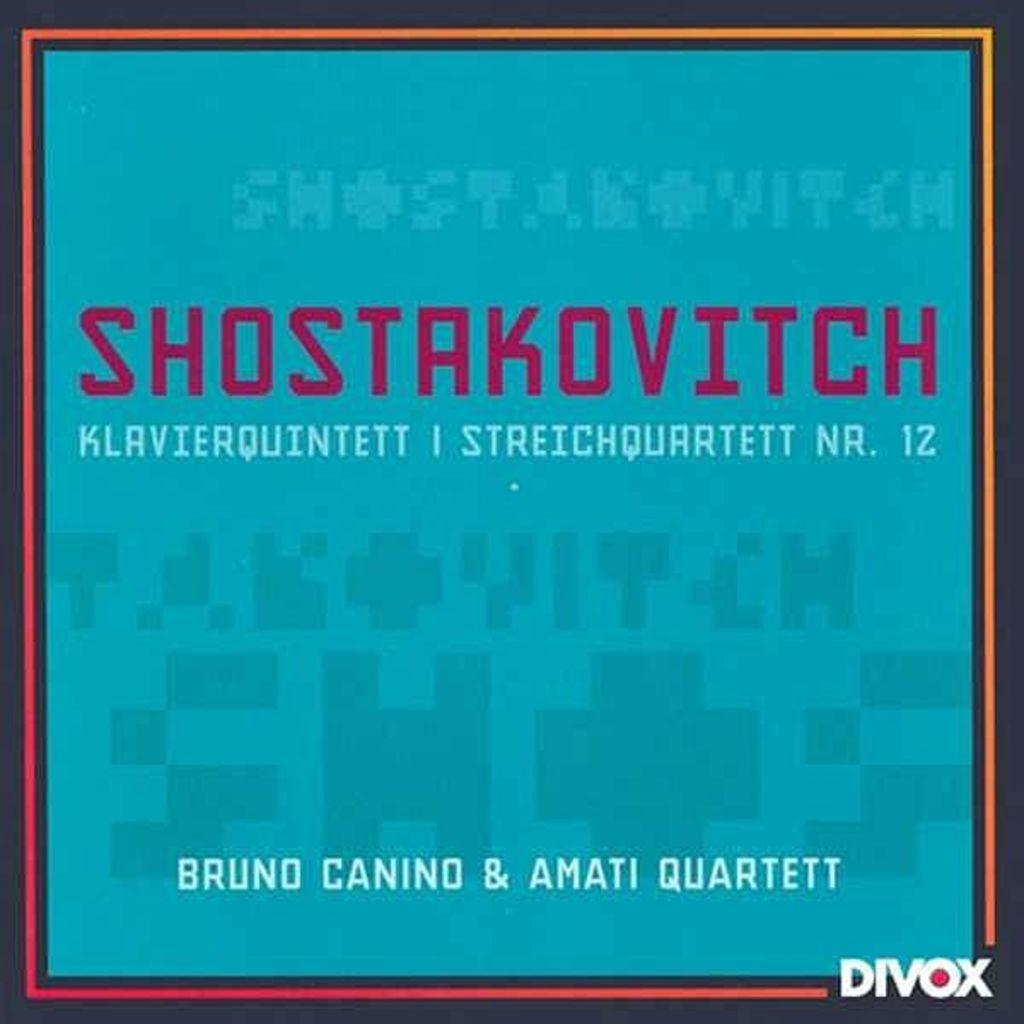<image>
Render a clear and concise summary of the photo. A poster with a blue background with the heading Shostakovitch. 